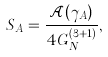<formula> <loc_0><loc_0><loc_500><loc_500>S _ { A } = \frac { \mathcal { A } ( \gamma _ { A } ) } { 4 G _ { N } ^ { ( 3 + 1 ) } } ,</formula> 